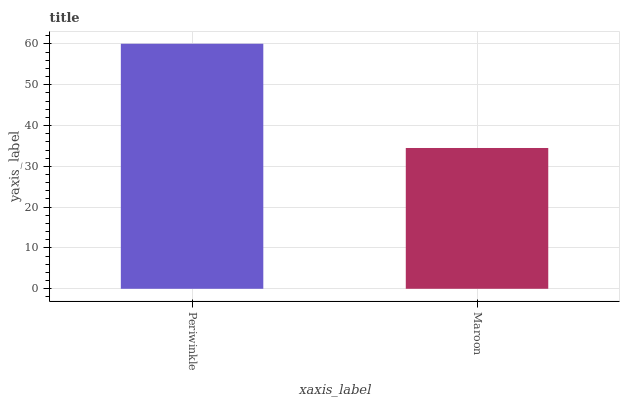Is Maroon the maximum?
Answer yes or no. No. Is Periwinkle greater than Maroon?
Answer yes or no. Yes. Is Maroon less than Periwinkle?
Answer yes or no. Yes. Is Maroon greater than Periwinkle?
Answer yes or no. No. Is Periwinkle less than Maroon?
Answer yes or no. No. Is Periwinkle the high median?
Answer yes or no. Yes. Is Maroon the low median?
Answer yes or no. Yes. Is Maroon the high median?
Answer yes or no. No. Is Periwinkle the low median?
Answer yes or no. No. 